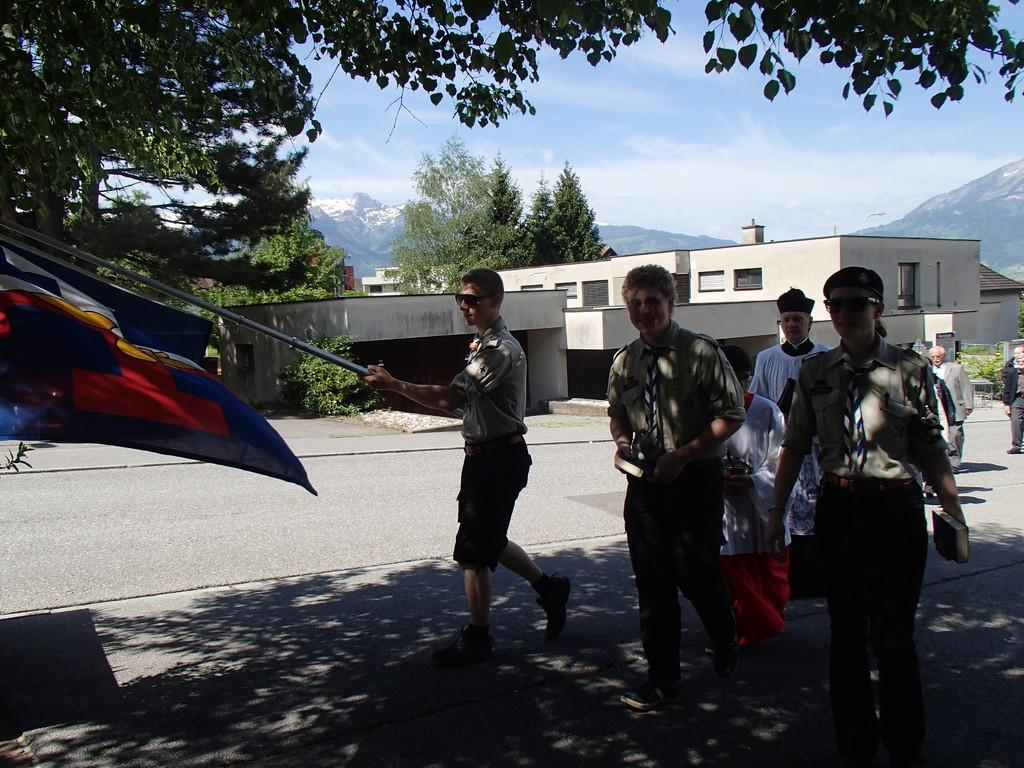What are the people in the image doing? The people in the image are walking on the road. Can you describe the person holding an object in the image? Yes, a person is holding a flag in the image. What are two other people holding in the image? Two people are holding books in the image. What can be seen in the background of the image? There are buildings, trees, and the sky visible in the background of the image. Where is the river flowing in the image? There is no river present in the image. Can you tell me the name of the doctor walking on the road in the image? There is no doctor or any indication of a doctor's presence in the image. 